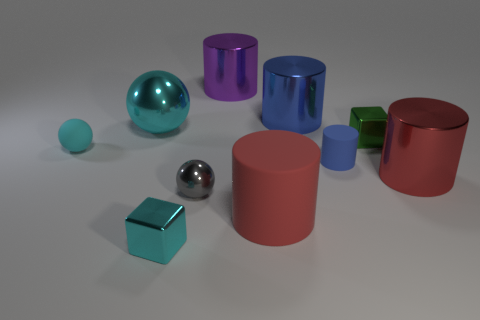Subtract all purple cylinders. How many cylinders are left? 4 Subtract all small rubber cylinders. How many cylinders are left? 4 Subtract all green cylinders. Subtract all brown spheres. How many cylinders are left? 5 Subtract all cubes. How many objects are left? 8 Subtract 0 purple spheres. How many objects are left? 10 Subtract all blue matte cylinders. Subtract all small metallic balls. How many objects are left? 8 Add 2 tiny green objects. How many tiny green objects are left? 3 Add 6 big yellow shiny things. How many big yellow shiny things exist? 6 